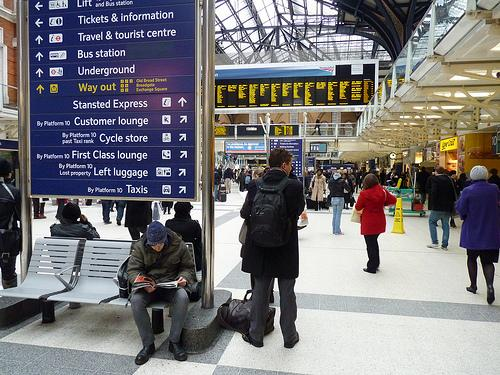What type of seating is available in the image? There are grey plastic seats in the image. Identify the colors of the coats worn by the women in the image. One woman is wearing a red coat, and another woman is wearing a blue coat. How would you describe the ambiance of the train station in the image? The ambiance in the image seems clean and well-organized, with clear signs and a bright, spacious design featuring a skylight. What color are the signs in the image and what type of text is on them? The signs are mostly blue with white writing, and they appear to be directive. What is the caution sign about in the image? The caution sign is a yellow wet floor sign, warning people about the potential danger of slipping. Count the number of people in the image, and describe any notable features. There are 5 people in the image, with one woman wearing a red coat, another woman with a blue coat, and a young man with short brown hair. What is the primary purpose of the yellow objects in the image? The yellow objects serve as cautionary signs for wet floors or potential hazards. Describe the flooring in the image. The flooring is white and grey tile. Describe the object on the floor next to the black duffle bag. Next to the black duffle bag, there is a yellow caution pylon for a wet floor. What kind of location is depicted in the image? The image depicts a train station or train stop. What color is the coat the woman is wearing in the image? Red What is the purpose of the signs in the image? It serves as directives What type of place is the image showcasing? A train station Identify the seating in the image and describe its material. Grey plastic seats How many people are there in the image? Four What type of bag can be found on the floor in the image? Black leather duffle bag What caution is the yellow pylon in the image conveying? Wet floor Which person in the image is writing? The person standing in the middle What is the color of the text on the blue signs? White Is there a sign cautioning for a wet floor in the image? Yes In the image, who has a backpack? The person towards the right-center Describe the object promoting caution in the image. A yellow wet floor sign Find the woman wearing a blue coat in the image. She is at the right-top corner What's the color of the signs in the image? Blue What is the material of the bench in the image? Metal Identify the person with short brown hair and their position in the image. Young man at the left-top corner Is there a skylight visible in the image? Yes, a glass and metal skylight Is one of the persons in the image wearing a red coat? Yes, the woman Which of the following items is located on the floor? a) A black duffle bag b) A yellow caution cone c) A woman wearing a blue coat a) A black duffle bag 